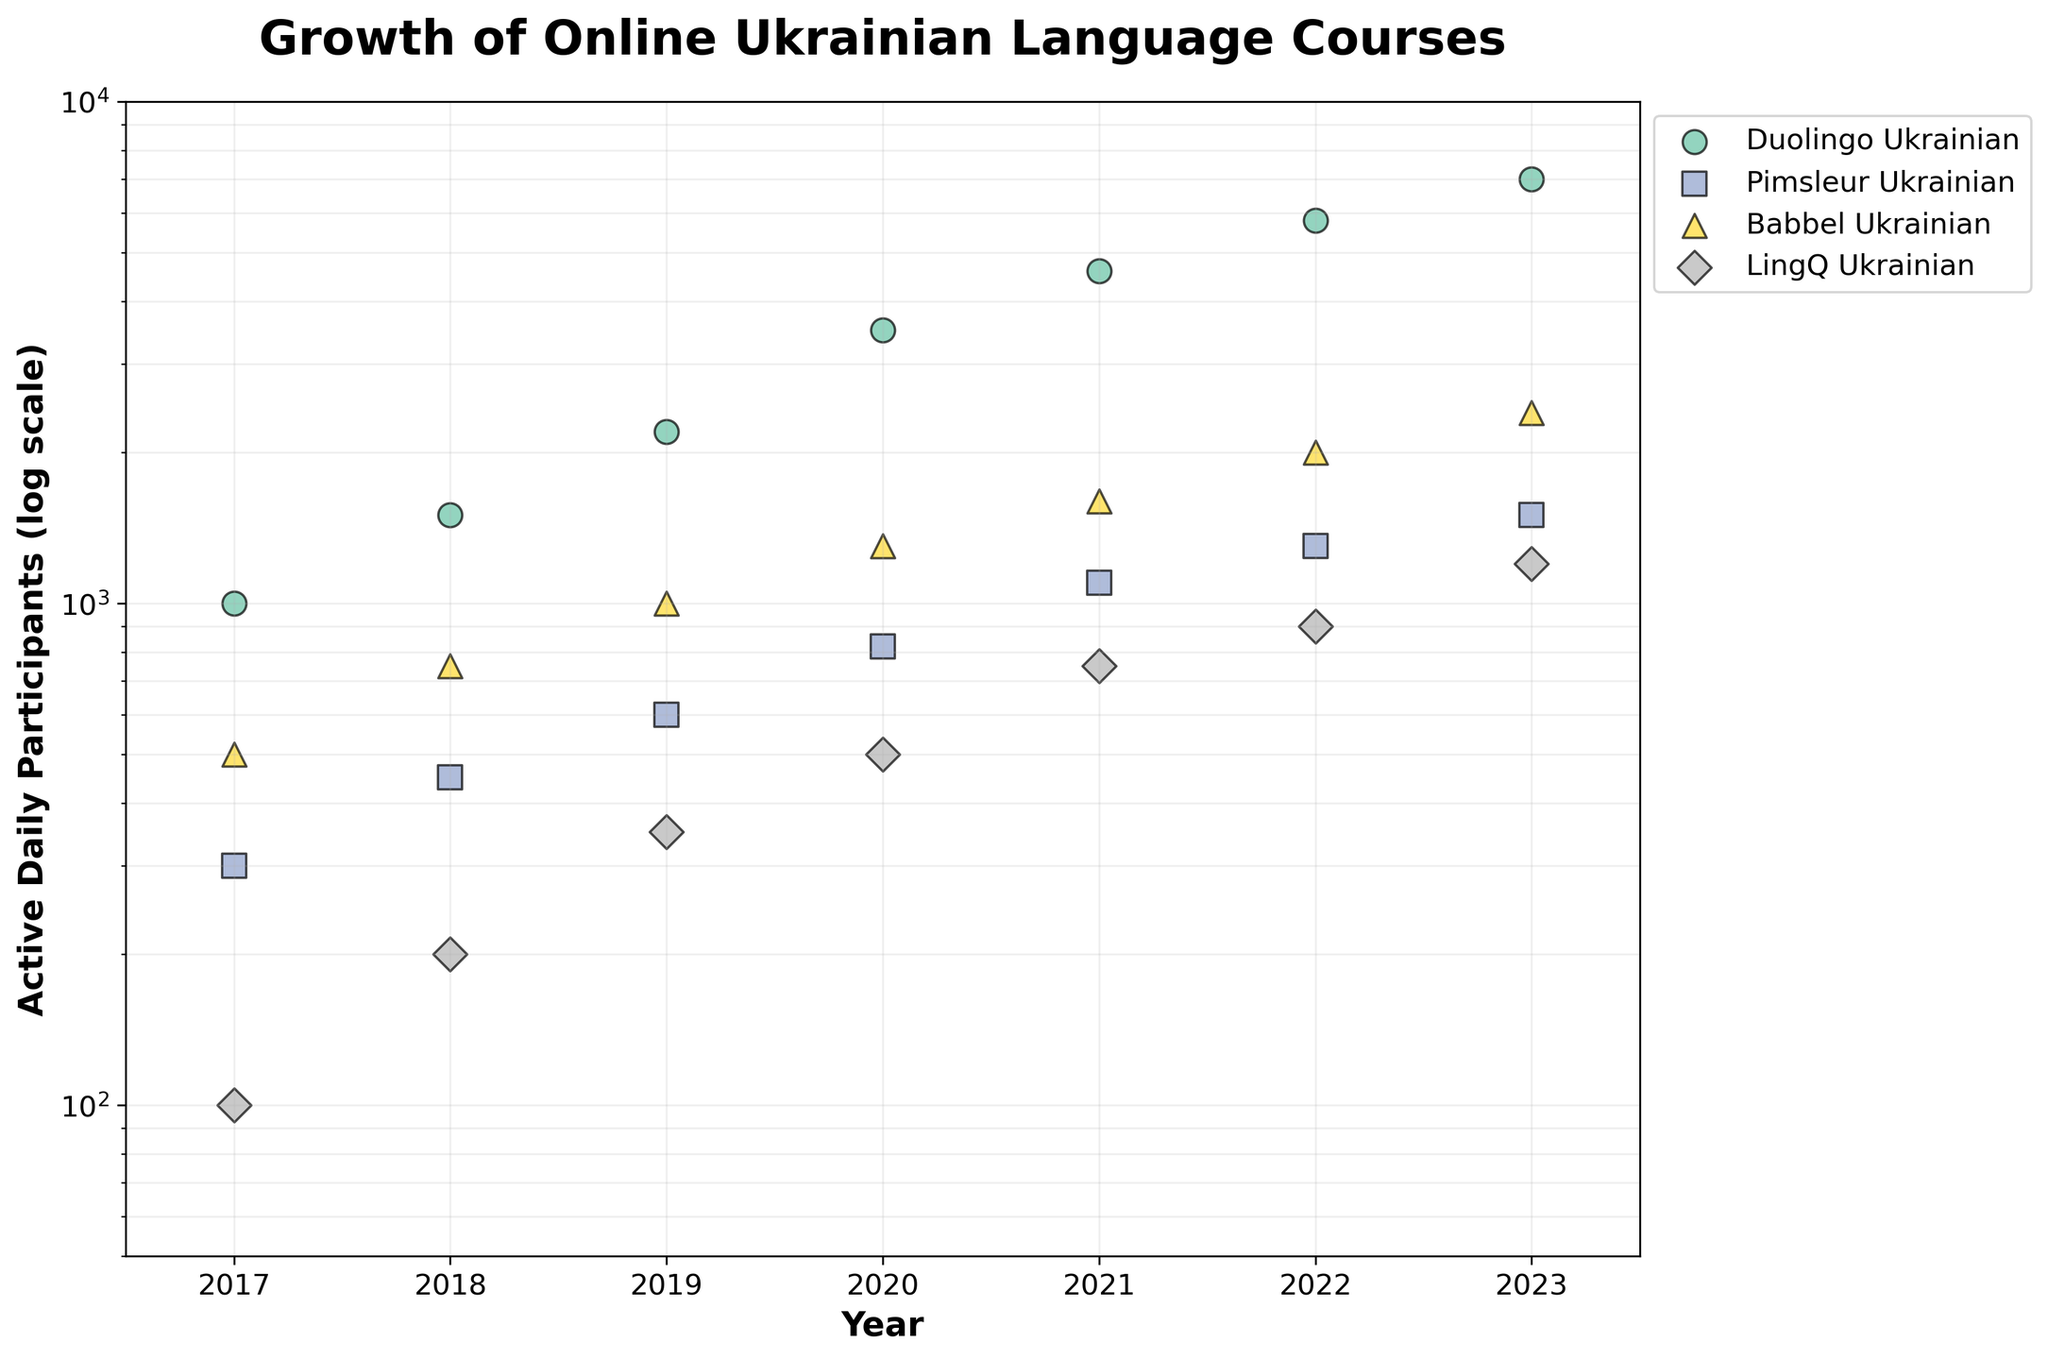How many courses are depicted in the figure? The legend in the figure shows four different courses: Duolingo Ukrainian, Pimsleur Ukrainian, Babbel Ukrainian, and LingQ Ukrainian. Thus, there are four courses depicted.
Answer: 4 Which course had the highest number of active daily participants in 2023? By looking at the scatter points for the year 2023 on the x-axis and identifying which one has the highest y-axis value, we see that Duolingo Ukrainian has the highest number of active daily participants.
Answer: Duolingo Ukrainian What is the range of active daily participants for LingQ Ukrainian over the years? From the scatter points of LingQ Ukrainian, the lowest y-axis value is 100 (in 2017) and the highest is 1200 (in 2023). Therefore, the range is 100 to 1200 participants.
Answer: 100 to 1200 Which course showed the most significant growth in active daily participants from 2017 to 2023? To answer this, we compare the first and last points of each course by measuring the vertical distance between the scatter points for 2017 and 2023. Duolingo Ukrainian showed the most significant growth, increasing from 1000 to 7000 participants.
Answer: Duolingo Ukrainian What is the median number of active daily participants for Babbel Ukrainian in the years shown? The relevant data points for Babbel Ukrainian are: 500, 750, 1000, 1300, 1600, 2000, 2400. Sorting these, the middle value (median) is 1300.
Answer: 1300 How did the active daily participants for Pimsleur Ukrainian change from 2019 to 2020? To find this, we look at the y-axis values for Pimsleur Ukrainian in 2019 and 2020, which are 600 and 820 respectively. The change in participants is 820 - 600 = 220.
Answer: Increased by 220 In which year did Duolingo Ukrainian have approximately 3500 active daily participants? Observing the scatter points for Duolingo Ukrainian, the point where the y-axis value is around 3500 corresponds to the year 2020.
Answer: 2020 Comparing Babbel Ukrainian and LingQ Ukrainian, which had a higher increase in participants from 2021 to 2022? For Babbel Ukrainian, the increase from 2021 to 2022 is 2000 - 1600 = 400. For LingQ Ukrainian, the increase is 900 - 750 = 150. Babbel Ukrainian had a higher increase.
Answer: Babbel Ukrainian Which course had more active daily participants in 2017, Pimsleur Ukrainian or Babbel Ukrainian? Looking at the scatter points for the year 2017, Pimsleur Ukrainian had 300 participants and Babbel Ukrainian had 500 participants, so Babbel Ukrainian had more participants.
Answer: Babbel Ukrainian 